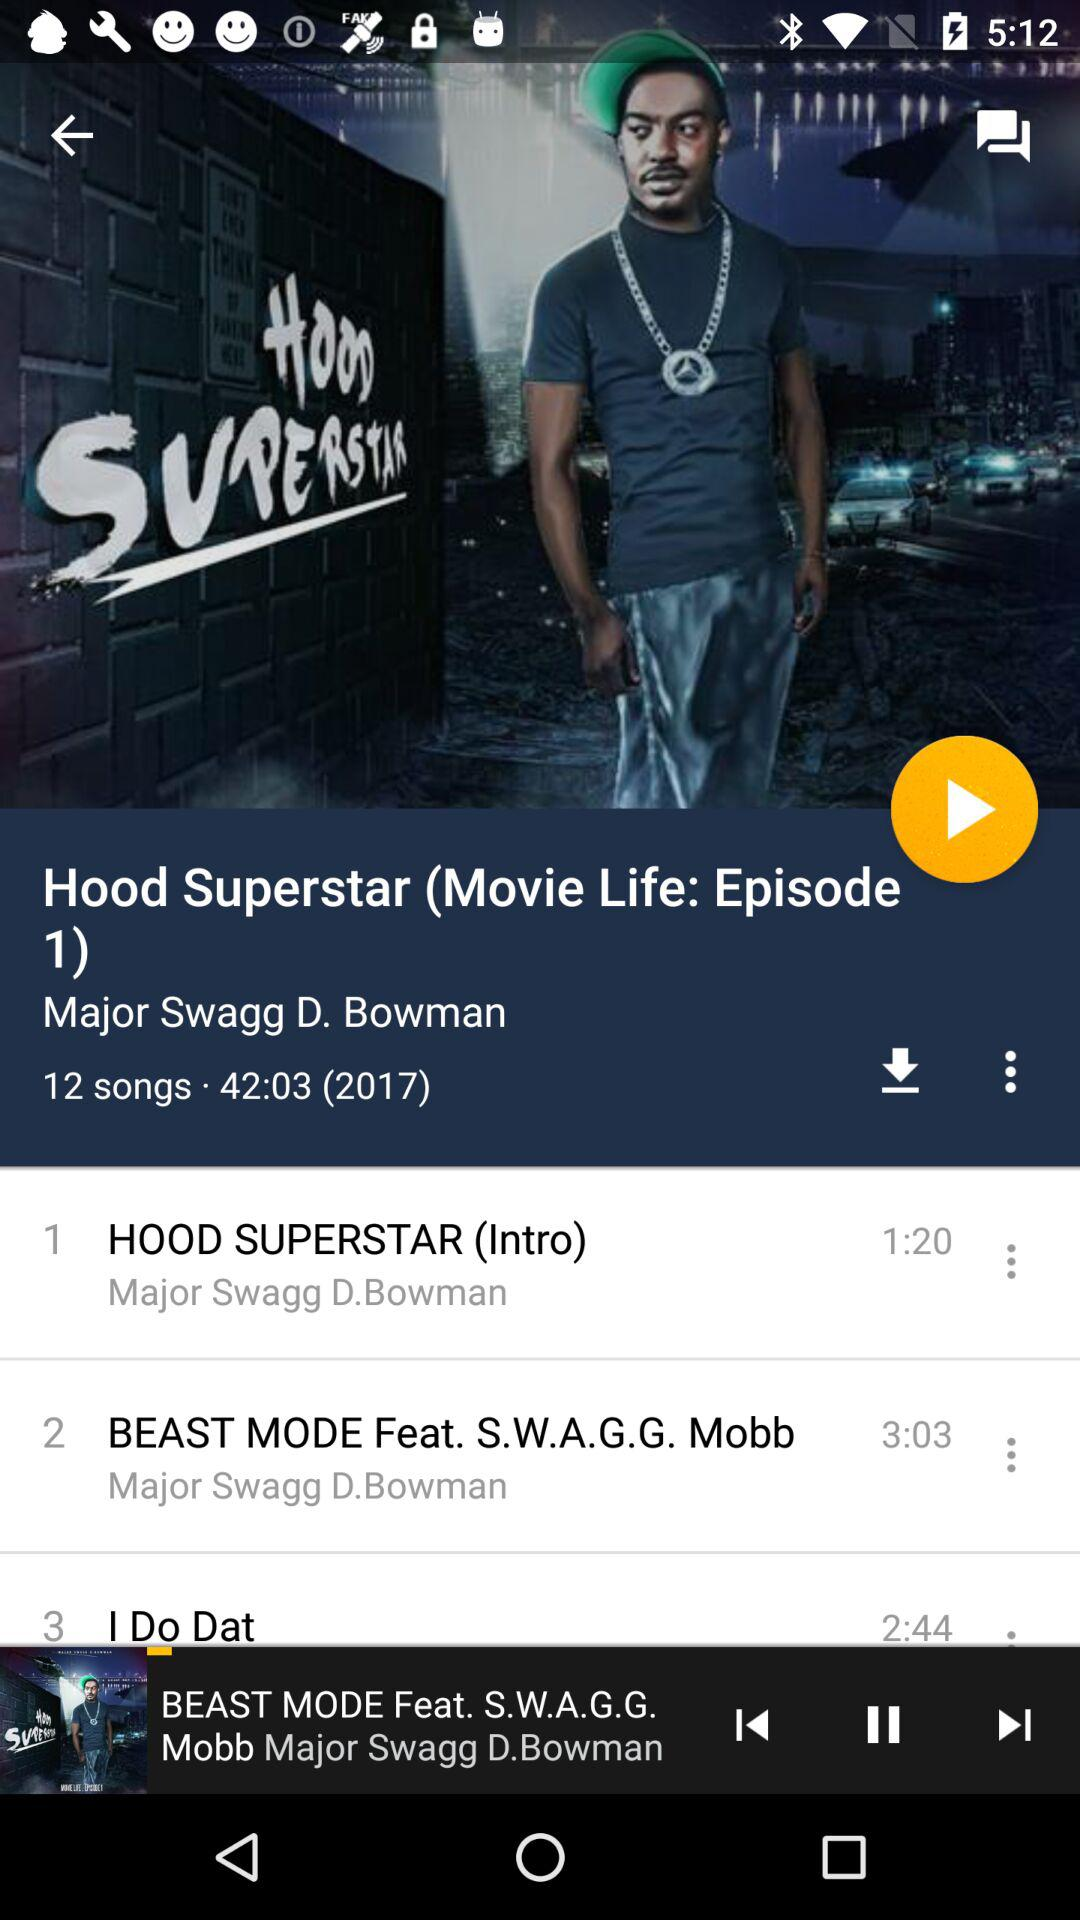How many songs are in the album?
Answer the question using a single word or phrase. 12 